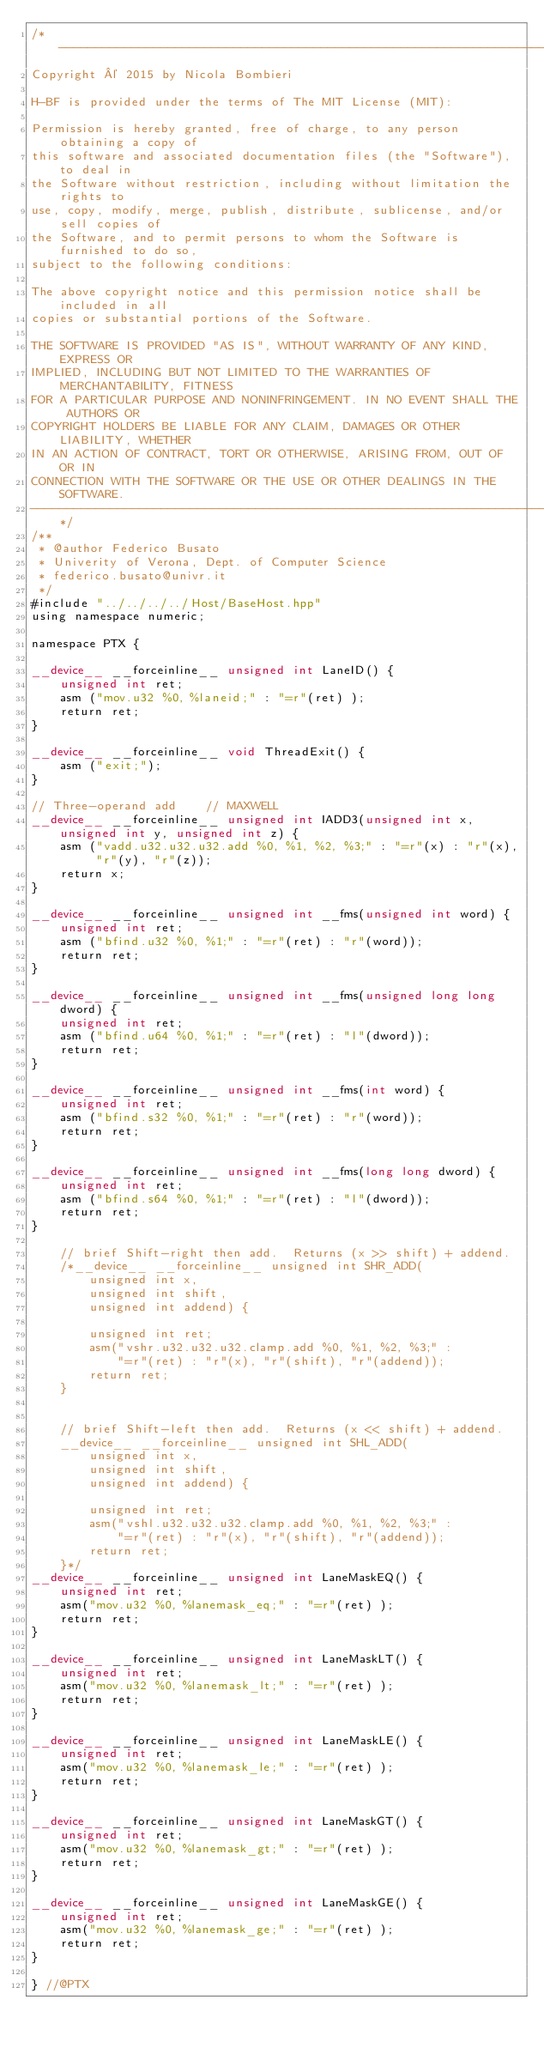<code> <loc_0><loc_0><loc_500><loc_500><_Cuda_>/*------------------------------------------------------------------------------
Copyright © 2015 by Nicola Bombieri

H-BF is provided under the terms of The MIT License (MIT):

Permission is hereby granted, free of charge, to any person obtaining a copy of
this software and associated documentation files (the "Software"), to deal in
the Software without restriction, including without limitation the rights to
use, copy, modify, merge, publish, distribute, sublicense, and/or sell copies of
the Software, and to permit persons to whom the Software is furnished to do so,
subject to the following conditions:

The above copyright notice and this permission notice shall be included in all
copies or substantial portions of the Software.

THE SOFTWARE IS PROVIDED "AS IS", WITHOUT WARRANTY OF ANY KIND, EXPRESS OR
IMPLIED, INCLUDING BUT NOT LIMITED TO THE WARRANTIES OF MERCHANTABILITY, FITNESS
FOR A PARTICULAR PURPOSE AND NONINFRINGEMENT. IN NO EVENT SHALL THE AUTHORS OR
COPYRIGHT HOLDERS BE LIABLE FOR ANY CLAIM, DAMAGES OR OTHER LIABILITY, WHETHER
IN AN ACTION OF CONTRACT, TORT OR OTHERWISE, ARISING FROM, OUT OF OR IN
CONNECTION WITH THE SOFTWARE OR THE USE OR OTHER DEALINGS IN THE SOFTWARE.
------------------------------------------------------------------------------*/
/**
 * @author Federico Busato
 * Univerity of Verona, Dept. of Computer Science
 * federico.busato@univr.it
 */
#include "../../../../Host/BaseHost.hpp"
using namespace numeric;

namespace PTX {

__device__ __forceinline__ unsigned int LaneID() {
    unsigned int ret;
    asm ("mov.u32 %0, %laneid;" : "=r"(ret) );
    return ret;
}

__device__ __forceinline__ void ThreadExit() {
	asm ("exit;");
}

// Three-operand add    // MAXWELL
__device__ __forceinline__ unsigned int IADD3(unsigned int x, unsigned int y, unsigned int z) {
	asm ("vadd.u32.u32.u32.add %0, %1, %2, %3;" : "=r"(x) : "r"(x), "r"(y), "r"(z));
	return x;
}

__device__ __forceinline__ unsigned int __fms(unsigned int word) {
    unsigned int ret;
    asm ("bfind.u32 %0, %1;" : "=r"(ret) : "r"(word));
    return ret;
}

__device__ __forceinline__ unsigned int __fms(unsigned long long dword) {
    unsigned int ret;
    asm ("bfind.u64 %0, %1;" : "=r"(ret) : "l"(dword));
    return ret;
}

__device__ __forceinline__ unsigned int __fms(int word) {
    unsigned int ret;
    asm ("bfind.s32 %0, %1;" : "=r"(ret) : "r"(word));
    return ret;
}

__device__ __forceinline__ unsigned int __fms(long long dword) {
    unsigned int ret;
    asm ("bfind.s64 %0, %1;" : "=r"(ret) : "l"(dword));
    return ret;
}

    // brief Shift-right then add.  Returns (x >> shift) + addend.
    /*__device__ __forceinline__ unsigned int SHR_ADD(
        unsigned int x,
        unsigned int shift,
        unsigned int addend) {

        unsigned int ret;
        asm("vshr.u32.u32.u32.clamp.add %0, %1, %2, %3;" :
            "=r"(ret) : "r"(x), "r"(shift), "r"(addend));
        return ret;
    }


    // brief Shift-left then add.  Returns (x << shift) + addend.
    __device__ __forceinline__ unsigned int SHL_ADD(
        unsigned int x,
        unsigned int shift,
        unsigned int addend) {

        unsigned int ret;
        asm("vshl.u32.u32.u32.clamp.add %0, %1, %2, %3;" :
            "=r"(ret) : "r"(x), "r"(shift), "r"(addend));
        return ret;
    }*/
__device__ __forceinline__ unsigned int LaneMaskEQ() {
	unsigned int ret;
	asm("mov.u32 %0, %lanemask_eq;" : "=r"(ret) );
	return ret;
}

__device__ __forceinline__ unsigned int LaneMaskLT() {
	unsigned int ret;
	asm("mov.u32 %0, %lanemask_lt;" : "=r"(ret) );
	return ret;
}

__device__ __forceinline__ unsigned int LaneMaskLE() {
	unsigned int ret;
	asm("mov.u32 %0, %lanemask_le;" : "=r"(ret) );
	return ret;
}

__device__ __forceinline__ unsigned int LaneMaskGT() {
	unsigned int ret;
	asm("mov.u32 %0, %lanemask_gt;" : "=r"(ret) );
	return ret;
}

__device__ __forceinline__ unsigned int LaneMaskGE() {
	unsigned int ret;
	asm("mov.u32 %0, %lanemask_ge;" : "=r"(ret) );
	return ret;
}

} //@PTX
</code> 